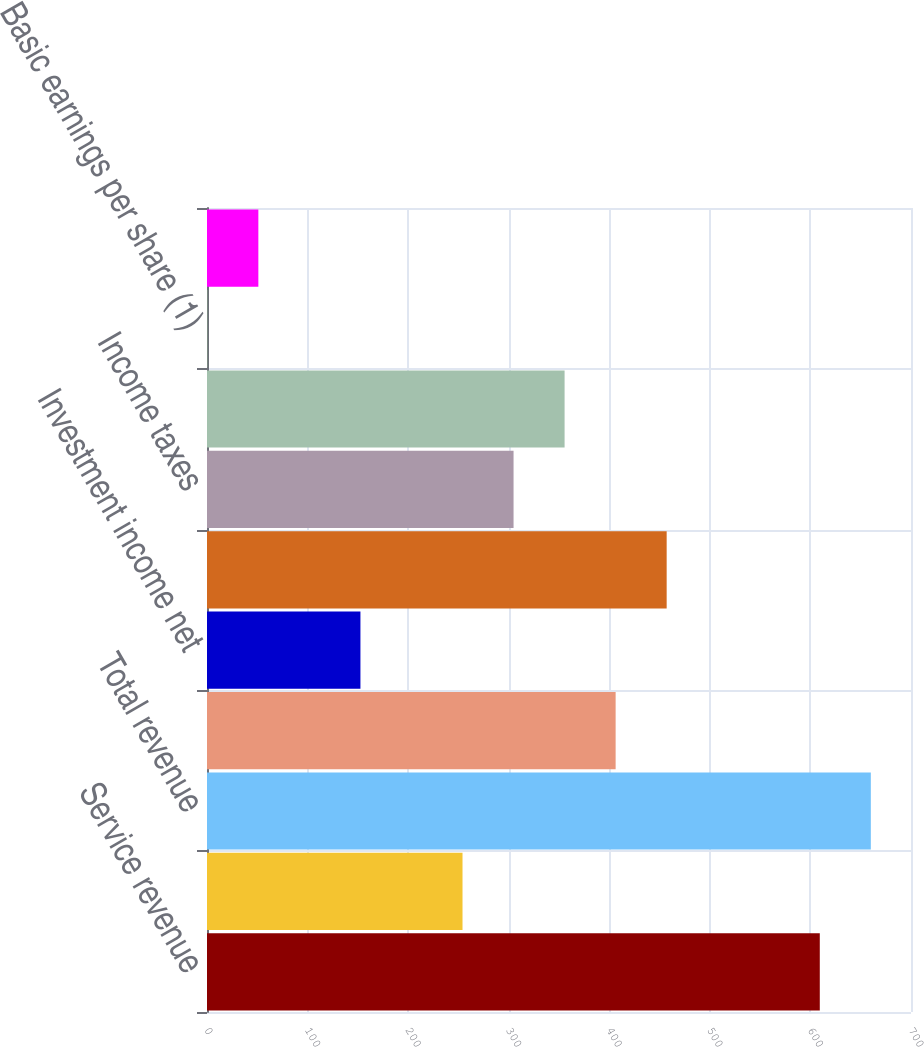Convert chart. <chart><loc_0><loc_0><loc_500><loc_500><bar_chart><fcel>Service revenue<fcel>Interest on funds held for<fcel>Total revenue<fcel>Operating income<fcel>Investment income net<fcel>Income before income taxes<fcel>Income taxes<fcel>Net income<fcel>Basic earnings per share (1)<fcel>Diluted earnings per share (1)<nl><fcel>609.31<fcel>254.06<fcel>660.06<fcel>406.31<fcel>152.56<fcel>457.06<fcel>304.81<fcel>355.56<fcel>0.31<fcel>51.06<nl></chart> 